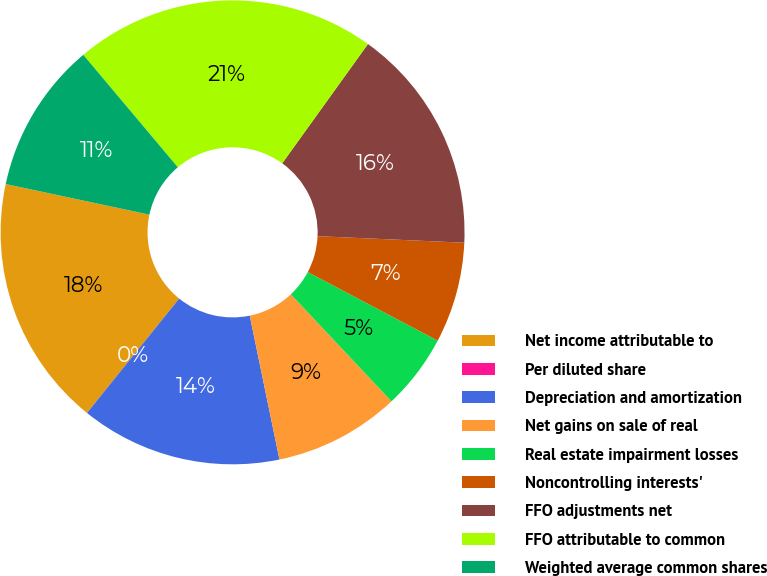Convert chart to OTSL. <chart><loc_0><loc_0><loc_500><loc_500><pie_chart><fcel>Net income attributable to<fcel>Per diluted share<fcel>Depreciation and amortization<fcel>Net gains on sale of real<fcel>Real estate impairment losses<fcel>Noncontrolling interests'<fcel>FFO adjustments net<fcel>FFO attributable to common<fcel>Weighted average common shares<nl><fcel>17.54%<fcel>0.0%<fcel>14.04%<fcel>8.77%<fcel>5.26%<fcel>7.02%<fcel>15.79%<fcel>21.05%<fcel>10.53%<nl></chart> 